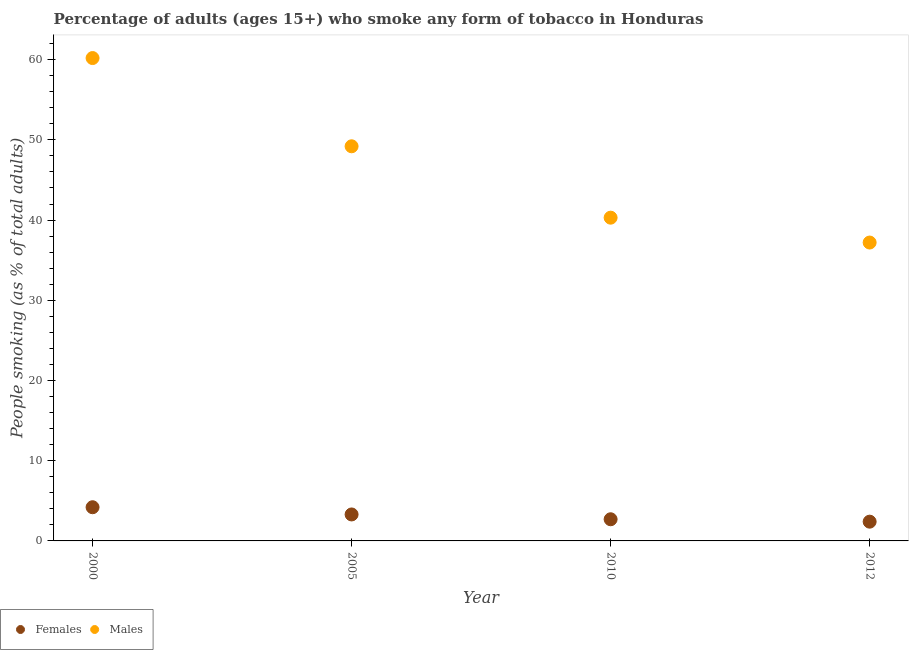Across all years, what is the maximum percentage of males who smoke?
Give a very brief answer. 60.2. Across all years, what is the minimum percentage of males who smoke?
Provide a short and direct response. 37.2. What is the total percentage of males who smoke in the graph?
Keep it short and to the point. 186.9. What is the difference between the percentage of males who smoke in 2012 and the percentage of females who smoke in 2005?
Your answer should be compact. 33.9. What is the average percentage of females who smoke per year?
Make the answer very short. 3.15. In how many years, is the percentage of females who smoke greater than 24 %?
Your answer should be very brief. 0. What is the ratio of the percentage of males who smoke in 2005 to that in 2010?
Offer a very short reply. 1.22. What is the difference between the highest and the second highest percentage of females who smoke?
Provide a short and direct response. 0.9. What is the difference between the highest and the lowest percentage of males who smoke?
Make the answer very short. 23. Is the sum of the percentage of males who smoke in 2000 and 2012 greater than the maximum percentage of females who smoke across all years?
Provide a succinct answer. Yes. Does the percentage of males who smoke monotonically increase over the years?
Your response must be concise. No. Is the percentage of males who smoke strictly less than the percentage of females who smoke over the years?
Keep it short and to the point. No. Are the values on the major ticks of Y-axis written in scientific E-notation?
Provide a succinct answer. No. Does the graph contain any zero values?
Provide a succinct answer. No. Does the graph contain grids?
Your answer should be compact. No. How are the legend labels stacked?
Your answer should be very brief. Horizontal. What is the title of the graph?
Offer a very short reply. Percentage of adults (ages 15+) who smoke any form of tobacco in Honduras. Does "Number of departures" appear as one of the legend labels in the graph?
Provide a succinct answer. No. What is the label or title of the X-axis?
Your response must be concise. Year. What is the label or title of the Y-axis?
Provide a short and direct response. People smoking (as % of total adults). What is the People smoking (as % of total adults) in Females in 2000?
Provide a short and direct response. 4.2. What is the People smoking (as % of total adults) in Males in 2000?
Your answer should be compact. 60.2. What is the People smoking (as % of total adults) in Males in 2005?
Make the answer very short. 49.2. What is the People smoking (as % of total adults) of Males in 2010?
Your response must be concise. 40.3. What is the People smoking (as % of total adults) of Males in 2012?
Your answer should be compact. 37.2. Across all years, what is the maximum People smoking (as % of total adults) in Males?
Ensure brevity in your answer.  60.2. Across all years, what is the minimum People smoking (as % of total adults) in Males?
Provide a short and direct response. 37.2. What is the total People smoking (as % of total adults) of Males in the graph?
Provide a short and direct response. 186.9. What is the difference between the People smoking (as % of total adults) of Females in 2000 and that in 2005?
Your answer should be compact. 0.9. What is the difference between the People smoking (as % of total adults) of Males in 2000 and that in 2005?
Provide a short and direct response. 11. What is the difference between the People smoking (as % of total adults) in Females in 2000 and that in 2010?
Provide a short and direct response. 1.5. What is the difference between the People smoking (as % of total adults) of Males in 2000 and that in 2010?
Offer a terse response. 19.9. What is the difference between the People smoking (as % of total adults) in Females in 2000 and that in 2012?
Provide a succinct answer. 1.8. What is the difference between the People smoking (as % of total adults) of Females in 2005 and that in 2010?
Offer a very short reply. 0.6. What is the difference between the People smoking (as % of total adults) in Females in 2005 and that in 2012?
Keep it short and to the point. 0.9. What is the difference between the People smoking (as % of total adults) in Females in 2000 and the People smoking (as % of total adults) in Males in 2005?
Your answer should be compact. -45. What is the difference between the People smoking (as % of total adults) in Females in 2000 and the People smoking (as % of total adults) in Males in 2010?
Your response must be concise. -36.1. What is the difference between the People smoking (as % of total adults) of Females in 2000 and the People smoking (as % of total adults) of Males in 2012?
Your response must be concise. -33. What is the difference between the People smoking (as % of total adults) in Females in 2005 and the People smoking (as % of total adults) in Males in 2010?
Ensure brevity in your answer.  -37. What is the difference between the People smoking (as % of total adults) of Females in 2005 and the People smoking (as % of total adults) of Males in 2012?
Give a very brief answer. -33.9. What is the difference between the People smoking (as % of total adults) in Females in 2010 and the People smoking (as % of total adults) in Males in 2012?
Provide a short and direct response. -34.5. What is the average People smoking (as % of total adults) in Females per year?
Provide a short and direct response. 3.15. What is the average People smoking (as % of total adults) in Males per year?
Make the answer very short. 46.73. In the year 2000, what is the difference between the People smoking (as % of total adults) in Females and People smoking (as % of total adults) in Males?
Your response must be concise. -56. In the year 2005, what is the difference between the People smoking (as % of total adults) of Females and People smoking (as % of total adults) of Males?
Offer a terse response. -45.9. In the year 2010, what is the difference between the People smoking (as % of total adults) of Females and People smoking (as % of total adults) of Males?
Offer a terse response. -37.6. In the year 2012, what is the difference between the People smoking (as % of total adults) of Females and People smoking (as % of total adults) of Males?
Offer a terse response. -34.8. What is the ratio of the People smoking (as % of total adults) in Females in 2000 to that in 2005?
Make the answer very short. 1.27. What is the ratio of the People smoking (as % of total adults) in Males in 2000 to that in 2005?
Provide a short and direct response. 1.22. What is the ratio of the People smoking (as % of total adults) of Females in 2000 to that in 2010?
Your response must be concise. 1.56. What is the ratio of the People smoking (as % of total adults) in Males in 2000 to that in 2010?
Your answer should be compact. 1.49. What is the ratio of the People smoking (as % of total adults) of Females in 2000 to that in 2012?
Provide a succinct answer. 1.75. What is the ratio of the People smoking (as % of total adults) of Males in 2000 to that in 2012?
Your answer should be compact. 1.62. What is the ratio of the People smoking (as % of total adults) of Females in 2005 to that in 2010?
Your answer should be very brief. 1.22. What is the ratio of the People smoking (as % of total adults) in Males in 2005 to that in 2010?
Ensure brevity in your answer.  1.22. What is the ratio of the People smoking (as % of total adults) of Females in 2005 to that in 2012?
Provide a short and direct response. 1.38. What is the ratio of the People smoking (as % of total adults) of Males in 2005 to that in 2012?
Give a very brief answer. 1.32. What is the ratio of the People smoking (as % of total adults) of Females in 2010 to that in 2012?
Offer a terse response. 1.12. What is the difference between the highest and the second highest People smoking (as % of total adults) of Females?
Offer a very short reply. 0.9. What is the difference between the highest and the lowest People smoking (as % of total adults) of Females?
Your answer should be compact. 1.8. 